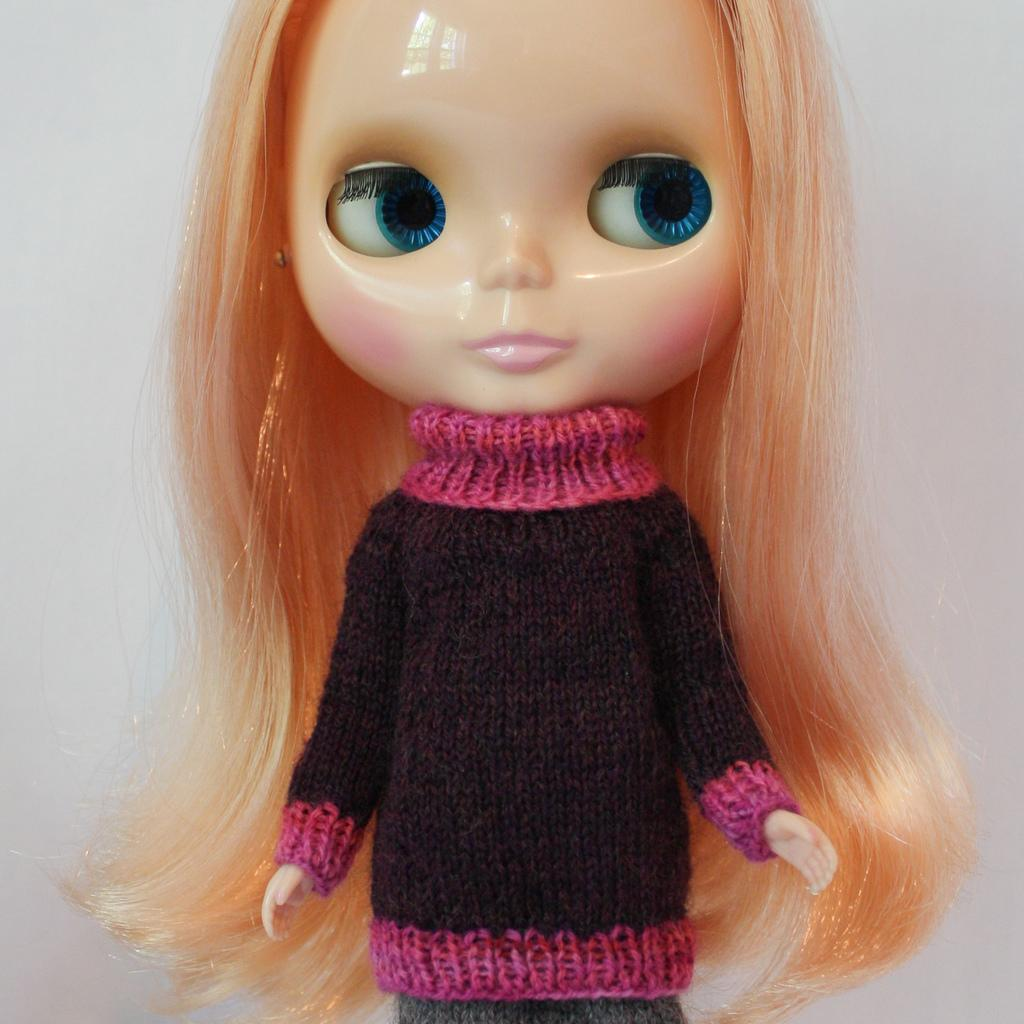Who is the main subject in the image? There is a girl in the image. What facial features of the girl can be seen in the image? The girl's eyes and nose are visible in the image. What is in the background of the image? There is a wall in the background of the image. What news is the girl reading from the cloth in the image? There is no cloth or news present in the image. 